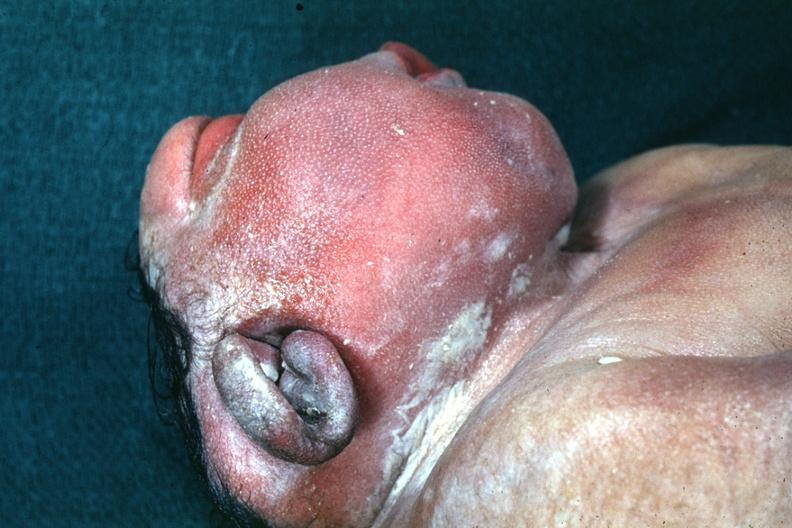what does this image show?
Answer the question using a single word or phrase. Lateral view of head typical example 